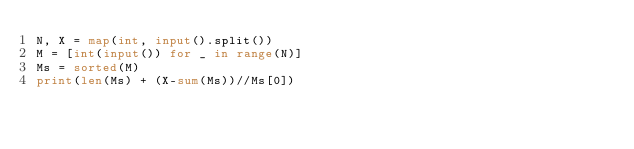Convert code to text. <code><loc_0><loc_0><loc_500><loc_500><_Python_>N, X = map(int, input().split())
M = [int(input()) for _ in range(N)]
Ms = sorted(M)
print(len(Ms) + (X-sum(Ms))//Ms[0])</code> 